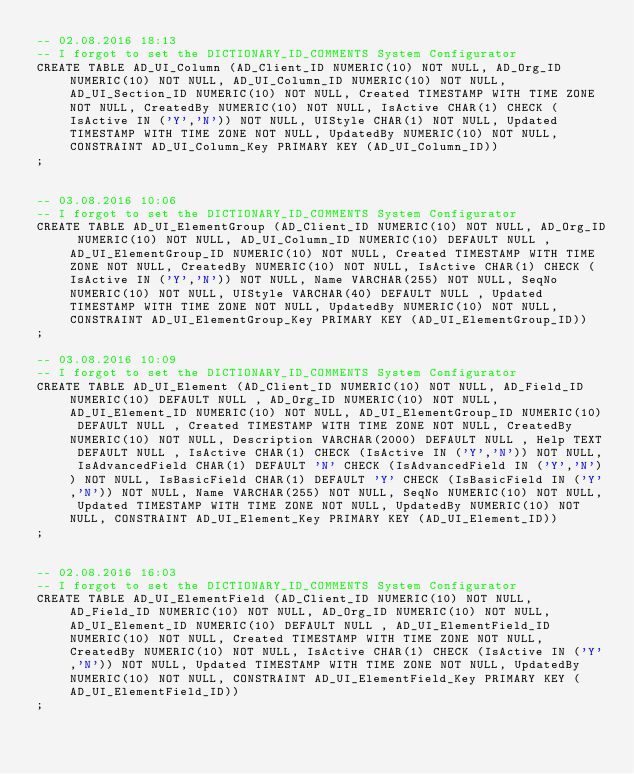Convert code to text. <code><loc_0><loc_0><loc_500><loc_500><_SQL_>-- 02.08.2016 18:13
-- I forgot to set the DICTIONARY_ID_COMMENTS System Configurator
CREATE TABLE AD_UI_Column (AD_Client_ID NUMERIC(10) NOT NULL, AD_Org_ID NUMERIC(10) NOT NULL, AD_UI_Column_ID NUMERIC(10) NOT NULL, AD_UI_Section_ID NUMERIC(10) NOT NULL, Created TIMESTAMP WITH TIME ZONE NOT NULL, CreatedBy NUMERIC(10) NOT NULL, IsActive CHAR(1) CHECK (IsActive IN ('Y','N')) NOT NULL, UIStyle CHAR(1) NOT NULL, Updated TIMESTAMP WITH TIME ZONE NOT NULL, UpdatedBy NUMERIC(10) NOT NULL, CONSTRAINT AD_UI_Column_Key PRIMARY KEY (AD_UI_Column_ID))
;


-- 03.08.2016 10:06
-- I forgot to set the DICTIONARY_ID_COMMENTS System Configurator
CREATE TABLE AD_UI_ElementGroup (AD_Client_ID NUMERIC(10) NOT NULL, AD_Org_ID NUMERIC(10) NOT NULL, AD_UI_Column_ID NUMERIC(10) DEFAULT NULL , AD_UI_ElementGroup_ID NUMERIC(10) NOT NULL, Created TIMESTAMP WITH TIME ZONE NOT NULL, CreatedBy NUMERIC(10) NOT NULL, IsActive CHAR(1) CHECK (IsActive IN ('Y','N')) NOT NULL, Name VARCHAR(255) NOT NULL, SeqNo NUMERIC(10) NOT NULL, UIStyle VARCHAR(40) DEFAULT NULL , Updated TIMESTAMP WITH TIME ZONE NOT NULL, UpdatedBy NUMERIC(10) NOT NULL, CONSTRAINT AD_UI_ElementGroup_Key PRIMARY KEY (AD_UI_ElementGroup_ID))
;

-- 03.08.2016 10:09
-- I forgot to set the DICTIONARY_ID_COMMENTS System Configurator
CREATE TABLE AD_UI_Element (AD_Client_ID NUMERIC(10) NOT NULL, AD_Field_ID NUMERIC(10) DEFAULT NULL , AD_Org_ID NUMERIC(10) NOT NULL, AD_UI_Element_ID NUMERIC(10) NOT NULL, AD_UI_ElementGroup_ID NUMERIC(10) DEFAULT NULL , Created TIMESTAMP WITH TIME ZONE NOT NULL, CreatedBy NUMERIC(10) NOT NULL, Description VARCHAR(2000) DEFAULT NULL , Help TEXT DEFAULT NULL , IsActive CHAR(1) CHECK (IsActive IN ('Y','N')) NOT NULL, IsAdvancedField CHAR(1) DEFAULT 'N' CHECK (IsAdvancedField IN ('Y','N')) NOT NULL, IsBasicField CHAR(1) DEFAULT 'Y' CHECK (IsBasicField IN ('Y','N')) NOT NULL, Name VARCHAR(255) NOT NULL, SeqNo NUMERIC(10) NOT NULL, Updated TIMESTAMP WITH TIME ZONE NOT NULL, UpdatedBy NUMERIC(10) NOT NULL, CONSTRAINT AD_UI_Element_Key PRIMARY KEY (AD_UI_Element_ID))
;


-- 02.08.2016 16:03
-- I forgot to set the DICTIONARY_ID_COMMENTS System Configurator
CREATE TABLE AD_UI_ElementField (AD_Client_ID NUMERIC(10) NOT NULL, AD_Field_ID NUMERIC(10) NOT NULL, AD_Org_ID NUMERIC(10) NOT NULL, AD_UI_Element_ID NUMERIC(10) DEFAULT NULL , AD_UI_ElementField_ID NUMERIC(10) NOT NULL, Created TIMESTAMP WITH TIME ZONE NOT NULL, CreatedBy NUMERIC(10) NOT NULL, IsActive CHAR(1) CHECK (IsActive IN ('Y','N')) NOT NULL, Updated TIMESTAMP WITH TIME ZONE NOT NULL, UpdatedBy NUMERIC(10) NOT NULL, CONSTRAINT AD_UI_ElementField_Key PRIMARY KEY (AD_UI_ElementField_ID))
;

</code> 